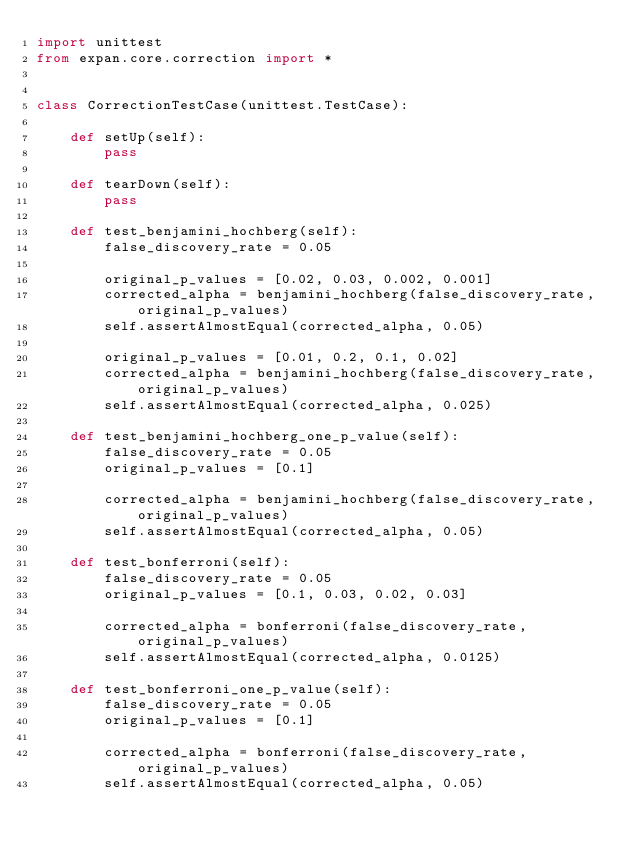<code> <loc_0><loc_0><loc_500><loc_500><_Python_>import unittest
from expan.core.correction import *


class CorrectionTestCase(unittest.TestCase):

    def setUp(self):
        pass

    def tearDown(self):
        pass

    def test_benjamini_hochberg(self):
        false_discovery_rate = 0.05

        original_p_values = [0.02, 0.03, 0.002, 0.001]
        corrected_alpha = benjamini_hochberg(false_discovery_rate, original_p_values)
        self.assertAlmostEqual(corrected_alpha, 0.05)

        original_p_values = [0.01, 0.2, 0.1, 0.02]
        corrected_alpha = benjamini_hochberg(false_discovery_rate, original_p_values)
        self.assertAlmostEqual(corrected_alpha, 0.025)

    def test_benjamini_hochberg_one_p_value(self):
        false_discovery_rate = 0.05
        original_p_values = [0.1]

        corrected_alpha = benjamini_hochberg(false_discovery_rate, original_p_values)
        self.assertAlmostEqual(corrected_alpha, 0.05)

    def test_bonferroni(self):
        false_discovery_rate = 0.05
        original_p_values = [0.1, 0.03, 0.02, 0.03]

        corrected_alpha = bonferroni(false_discovery_rate, original_p_values)
        self.assertAlmostEqual(corrected_alpha, 0.0125)

    def test_bonferroni_one_p_value(self):
        false_discovery_rate = 0.05
        original_p_values = [0.1]

        corrected_alpha = bonferroni(false_discovery_rate, original_p_values)
        self.assertAlmostEqual(corrected_alpha, 0.05)
</code> 